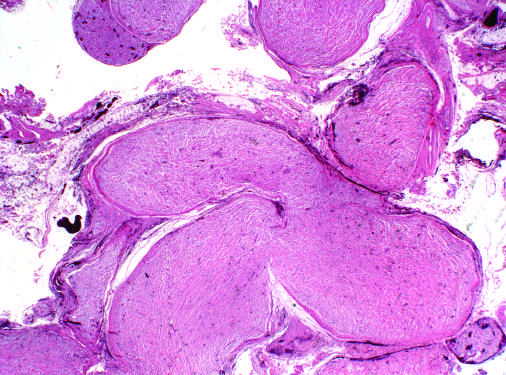re multiple nerve fascicles expanded by infiltrating tumor cells?
Answer the question using a single word or phrase. Yes 